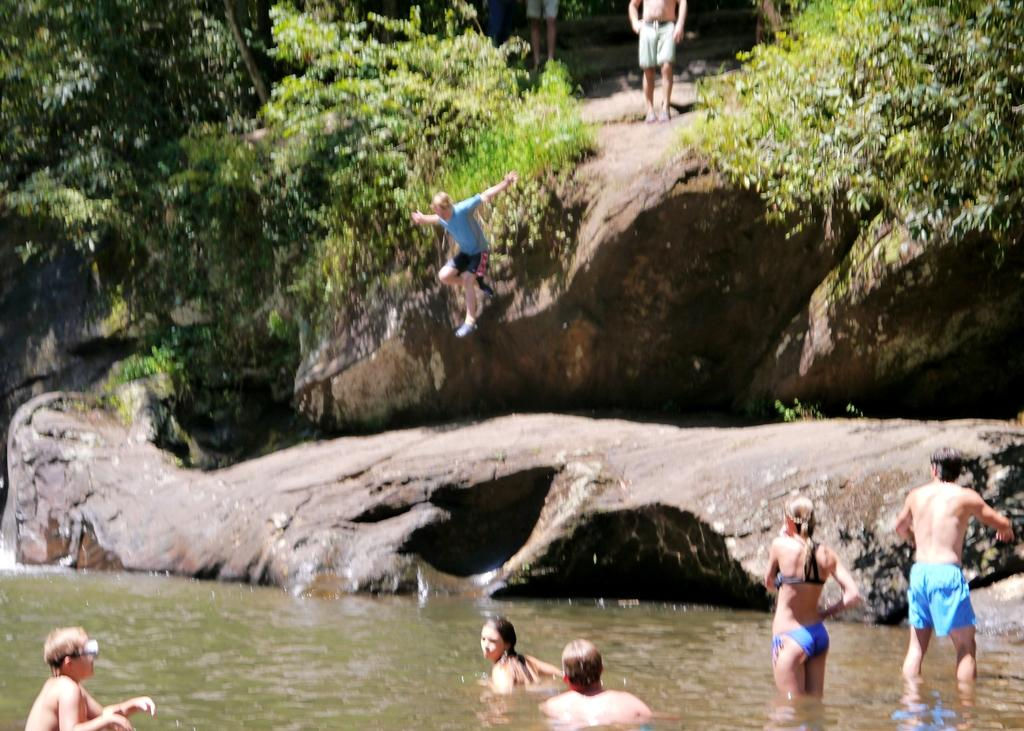What are the persons in the image doing on the rocks? There are persons standing on rocks in the image. What can be seen in the background of the image? Trees are visible in the image. What action is one person performing in the image? A person is jumping from a rock in the image. Where are some of the persons located in relation to the rocks? There are persons standing in the water in the image. Can you see a hydrant in the image? There is no hydrant present in the image. How many birds are in the flock near the trees in the image? There is no flock of birds present in the image; only persons, rocks, trees, and water are visible. 